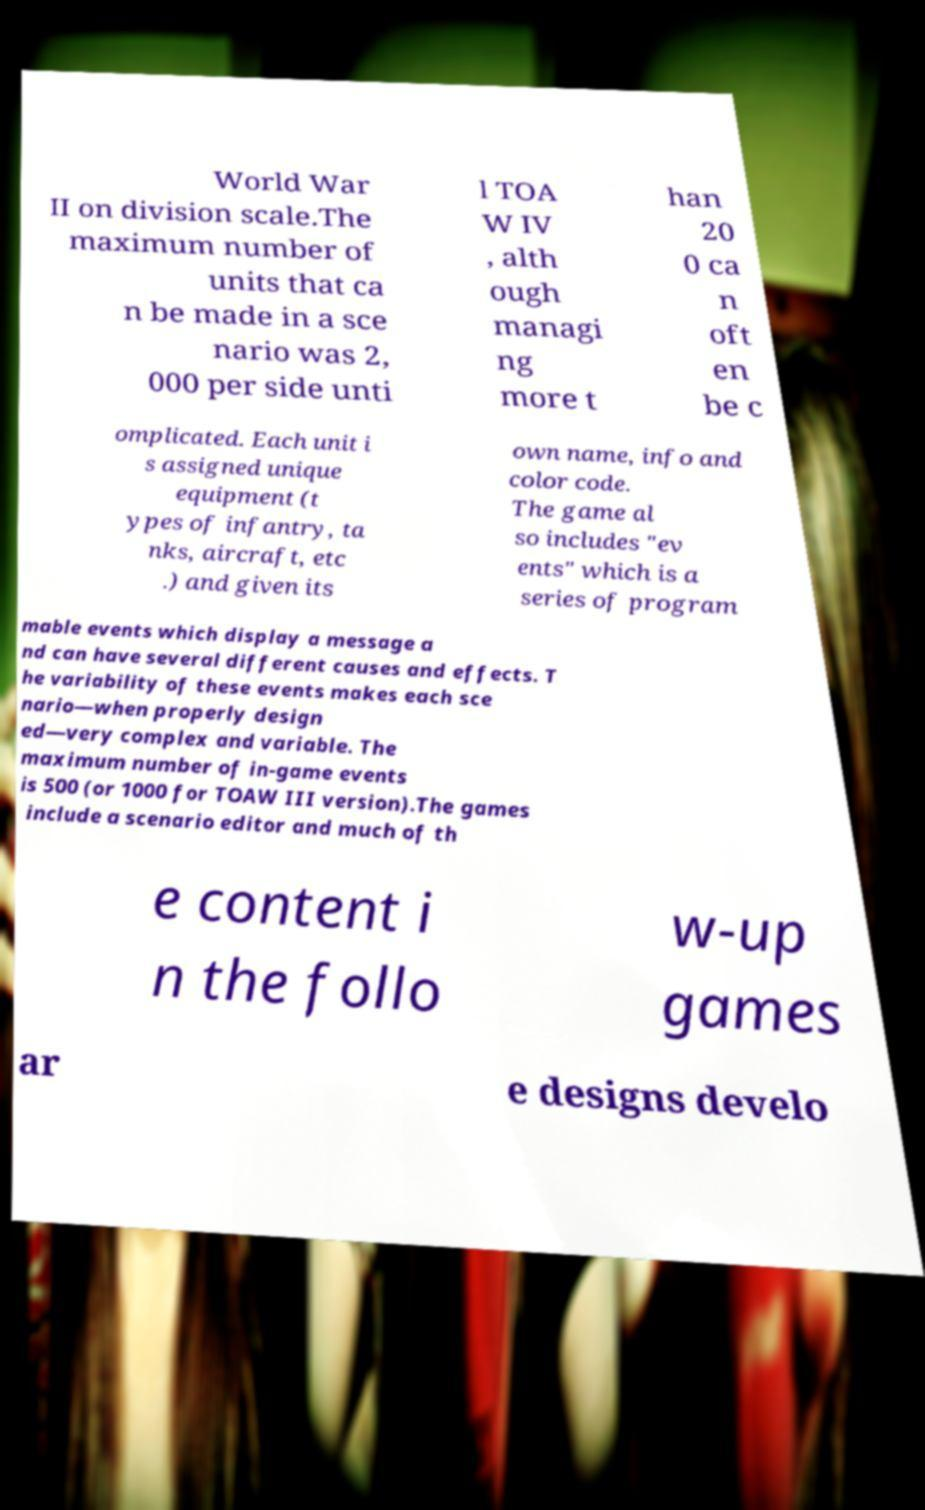I need the written content from this picture converted into text. Can you do that? World War II on division scale.The maximum number of units that ca n be made in a sce nario was 2, 000 per side unti l TOA W IV , alth ough managi ng more t han 20 0 ca n oft en be c omplicated. Each unit i s assigned unique equipment (t ypes of infantry, ta nks, aircraft, etc .) and given its own name, info and color code. The game al so includes "ev ents" which is a series of program mable events which display a message a nd can have several different causes and effects. T he variability of these events makes each sce nario—when properly design ed—very complex and variable. The maximum number of in-game events is 500 (or 1000 for TOAW III version).The games include a scenario editor and much of th e content i n the follo w-up games ar e designs develo 